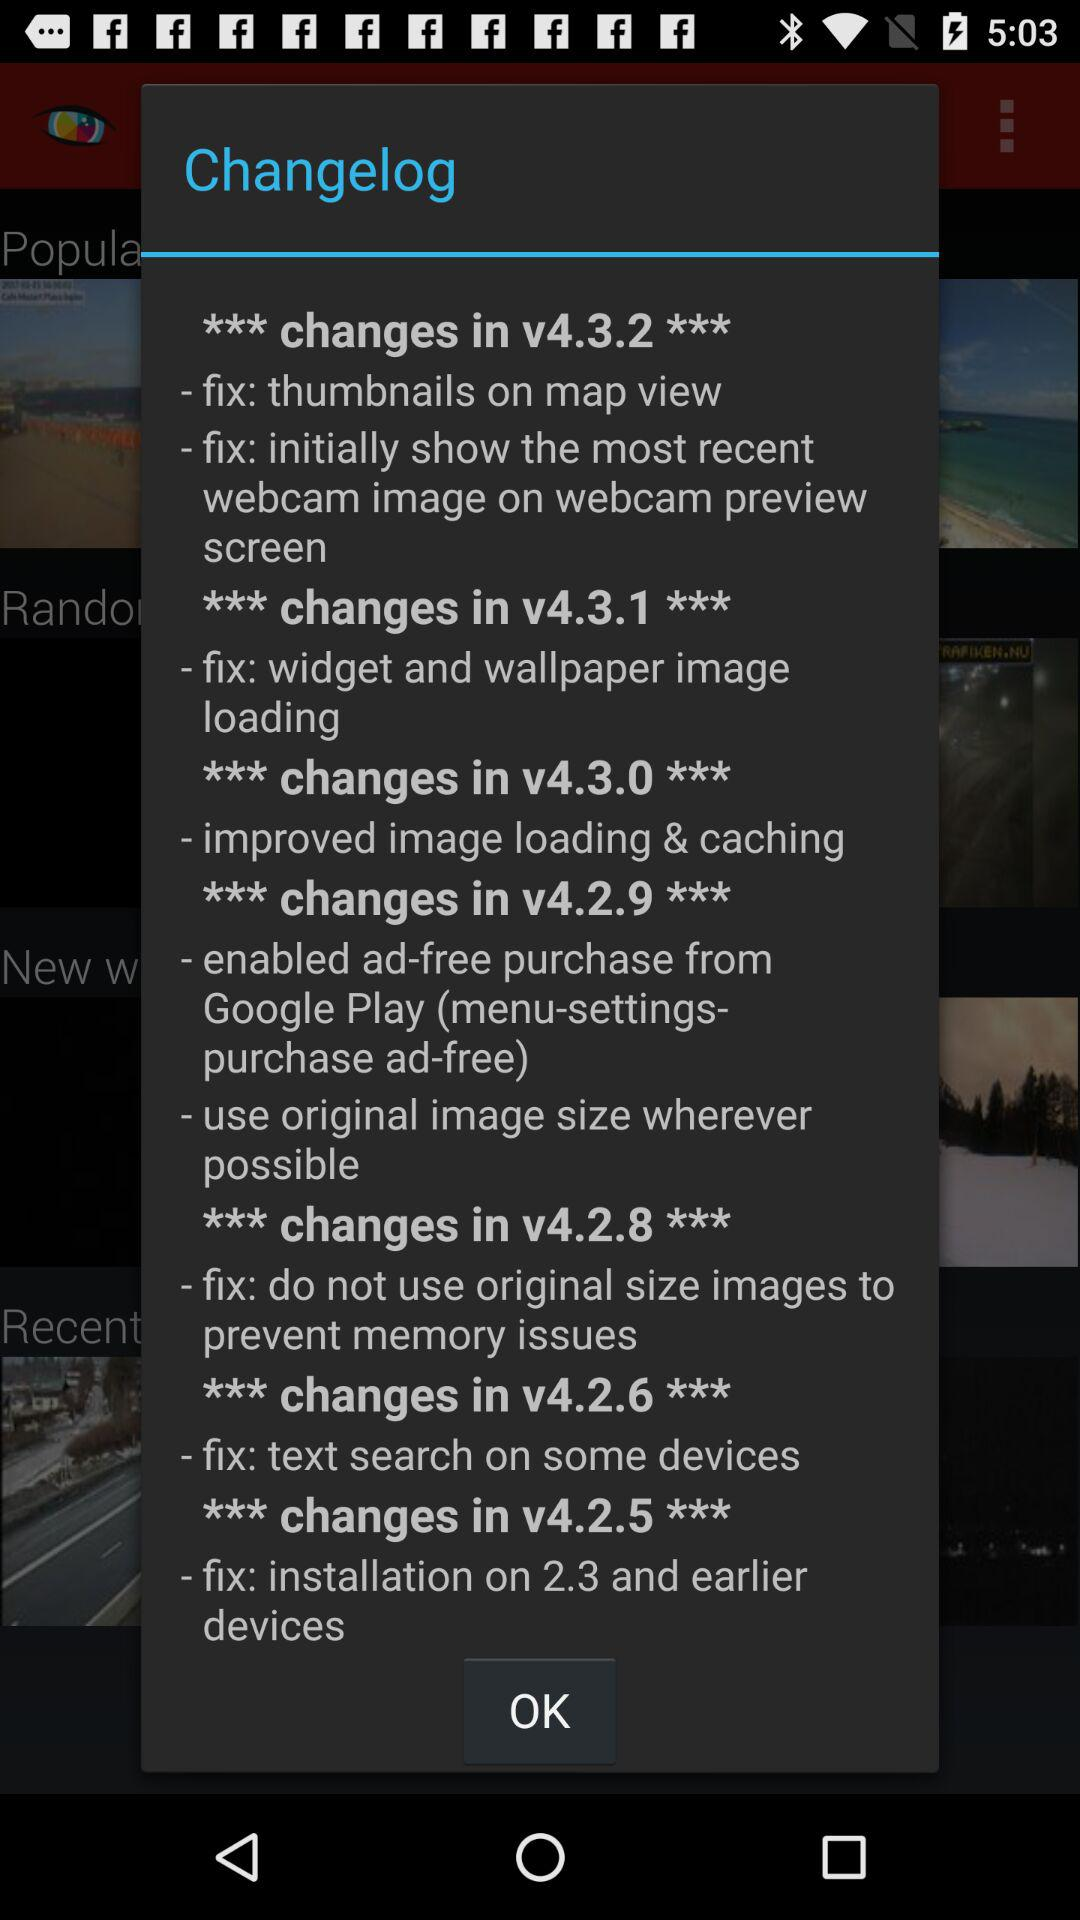Which are the different versions? The different versions are v4.3.2, v4.3.1, v4.3.0, v4.2.9, v4.2.8, v4.2.6 and v4.2.5. 